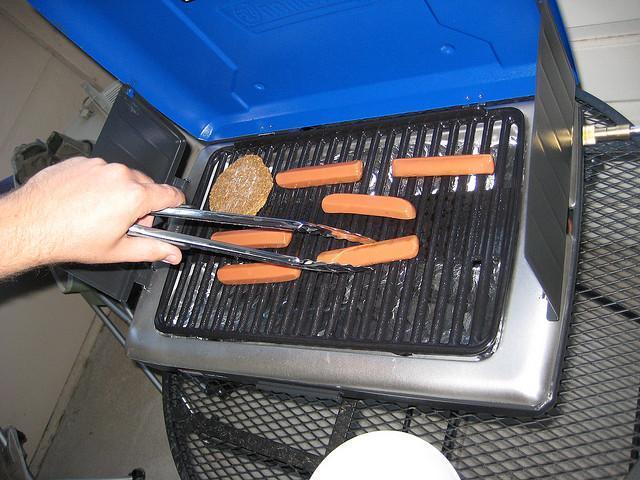How many giraffes are shorter that the lamp post?
Give a very brief answer. 0. 